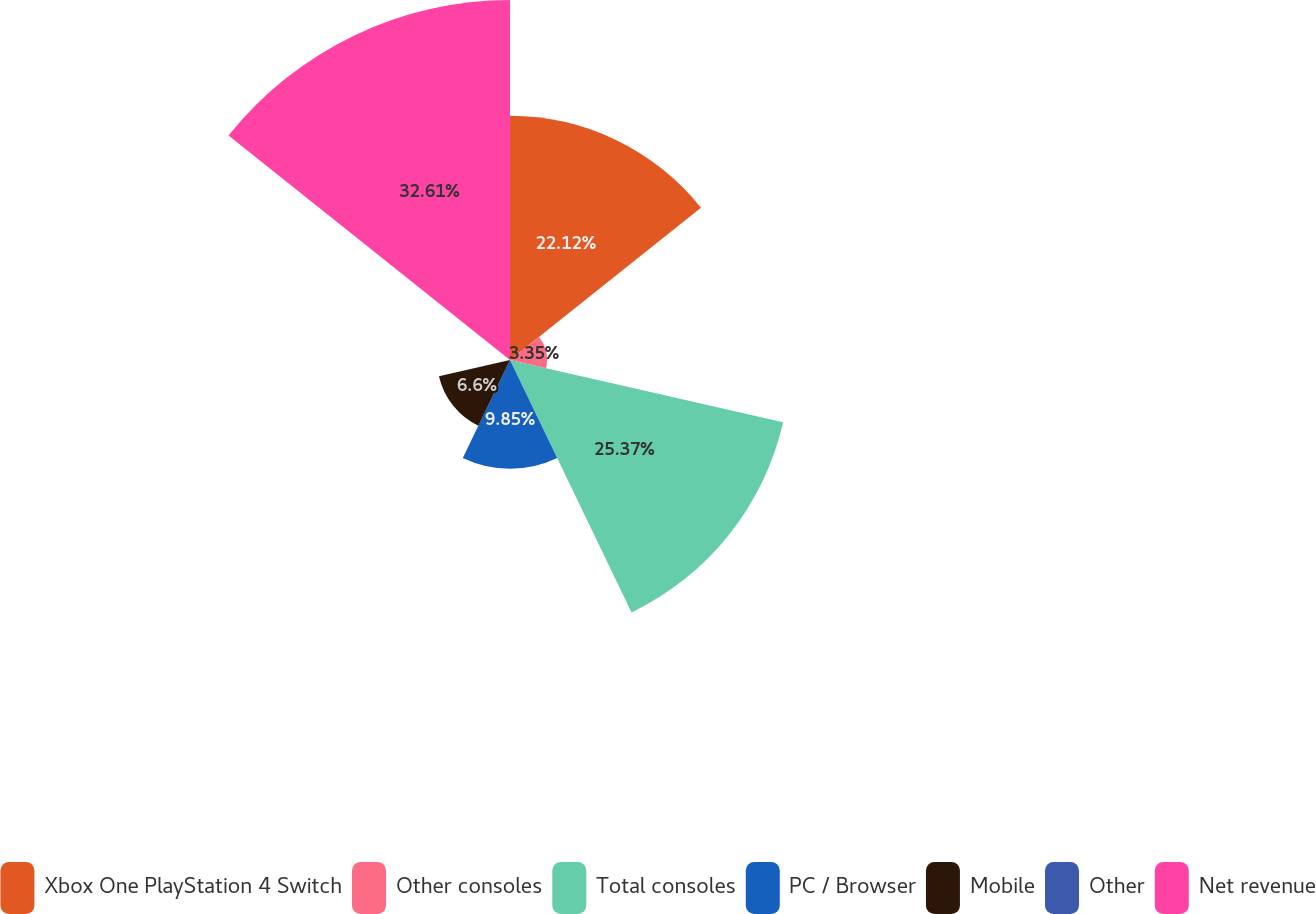<chart> <loc_0><loc_0><loc_500><loc_500><pie_chart><fcel>Xbox One PlayStation 4 Switch<fcel>Other consoles<fcel>Total consoles<fcel>PC / Browser<fcel>Mobile<fcel>Other<fcel>Net revenue<nl><fcel>22.12%<fcel>3.35%<fcel>25.37%<fcel>9.85%<fcel>6.6%<fcel>0.1%<fcel>32.6%<nl></chart> 